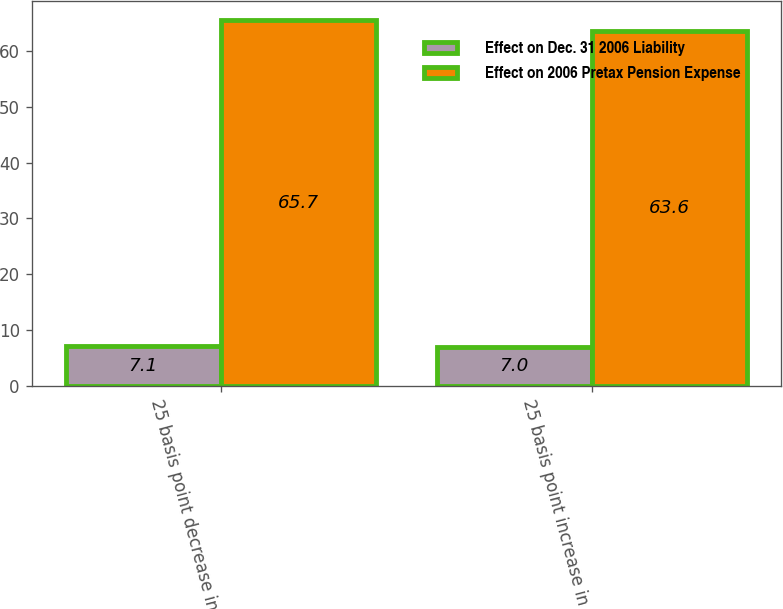<chart> <loc_0><loc_0><loc_500><loc_500><stacked_bar_chart><ecel><fcel>25 basis point decrease in<fcel>25 basis point increase in<nl><fcel>Effect on Dec. 31 2006 Liability<fcel>7.1<fcel>7<nl><fcel>Effect on 2006 Pretax Pension Expense<fcel>65.7<fcel>63.6<nl></chart> 